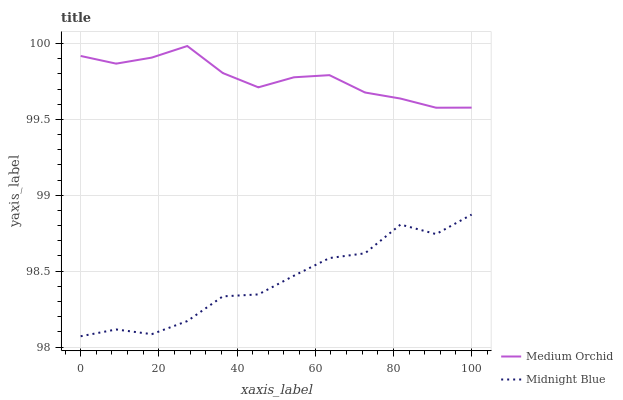Does Midnight Blue have the maximum area under the curve?
Answer yes or no. No. Is Midnight Blue the smoothest?
Answer yes or no. No. Does Midnight Blue have the highest value?
Answer yes or no. No. Is Midnight Blue less than Medium Orchid?
Answer yes or no. Yes. Is Medium Orchid greater than Midnight Blue?
Answer yes or no. Yes. Does Midnight Blue intersect Medium Orchid?
Answer yes or no. No. 